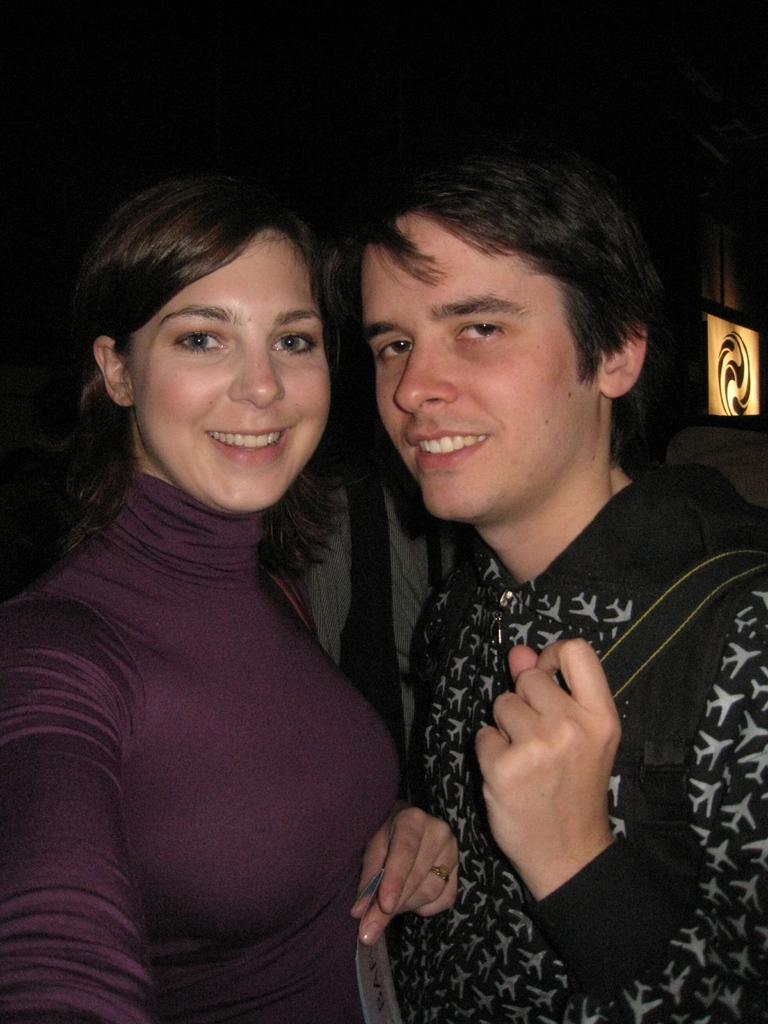How many people are in the image? There are two persons standing in the image. What is the facial expression of the persons in the image? The persons are smiling. What can be seen on the right side of the image? There is a board on the right side of the image. What is the color of the background in the image? The background of the image is dark. What type of plantation can be seen in the background of the image? There is no plantation visible in the image; the background is dark. What is the self-awareness level of the persons in the image? There is no information about the self-awareness level of the persons in the image, as it is not a relevant or observable detail in the image. 